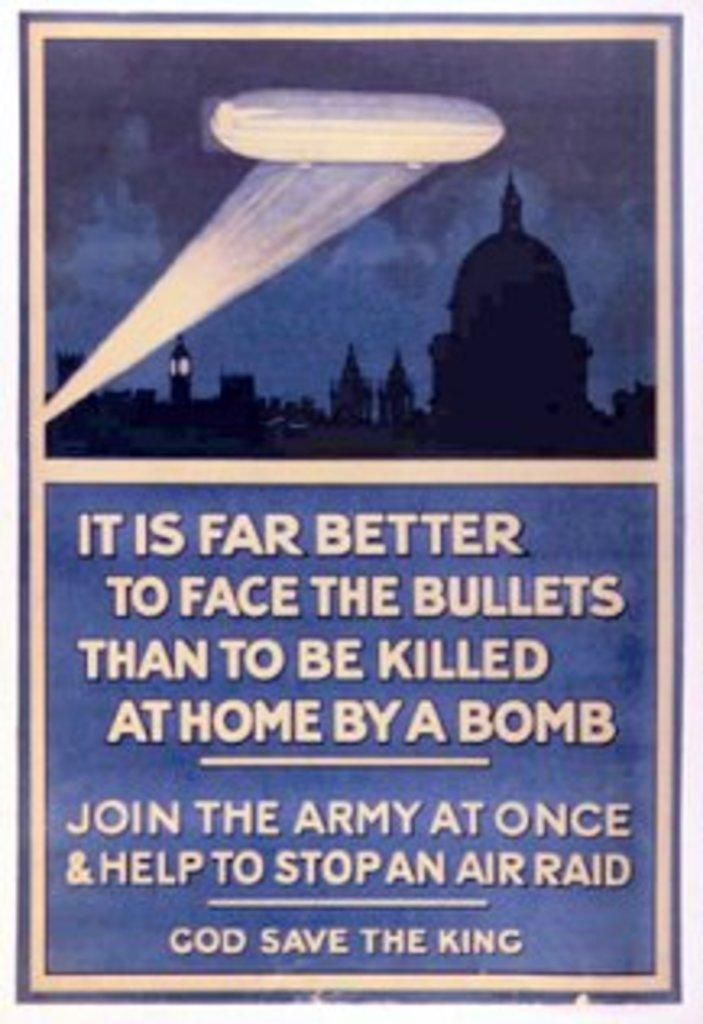Provide a one-sentence caption for the provided image. An old poster that says "It is far better to face bullets than to be killed at home by a bomb". 